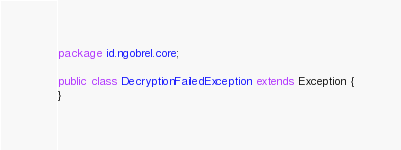Convert code to text. <code><loc_0><loc_0><loc_500><loc_500><_Java_>package id.ngobrel.core;

public class DecryptionFailedException extends Exception {
}
</code> 